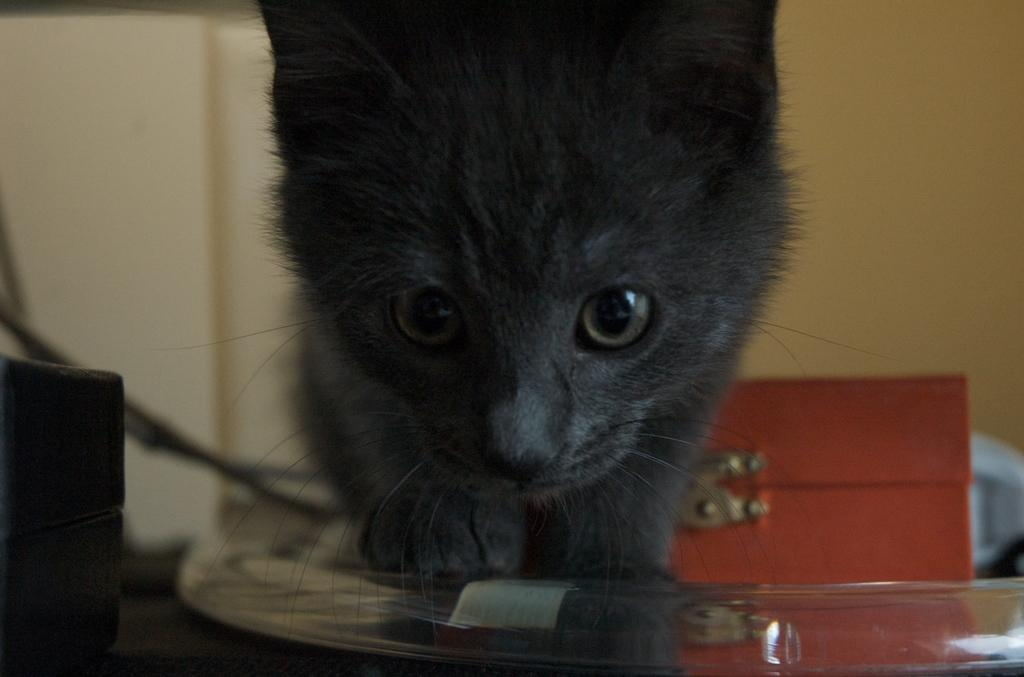What type of animal is in the image? There is a black color cat in the image. What can be seen in the background of the image? The background of the image includes a brown color thing. How would you describe the clarity of the image? The image is slightly blurry in the background. How many ducks are visible in the image? There are no ducks present in the image; it features a black color cat. What type of fuel is being used by the goose in the image? There is no goose present in the image, and therefore no fuel usage can be observed. 